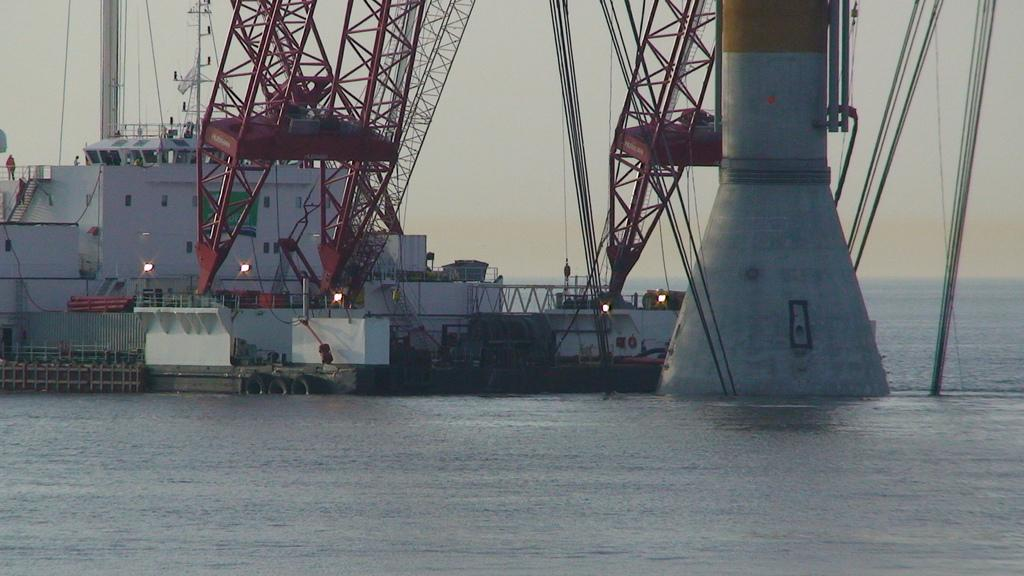What is the main subject of the image? The main subject of the image is a ship. What other objects can be seen in the water in the image? There are cranes and a pillar in the water in the image. What is visible in the background of the image? The sky is visible in the background of the image. Can you see a giraffe standing near the ship in the image? No, there is no giraffe present in the image. What type of coil is being used to secure the ship in the image? There is no coil visible in the image; the ship is not secured by any coil. 